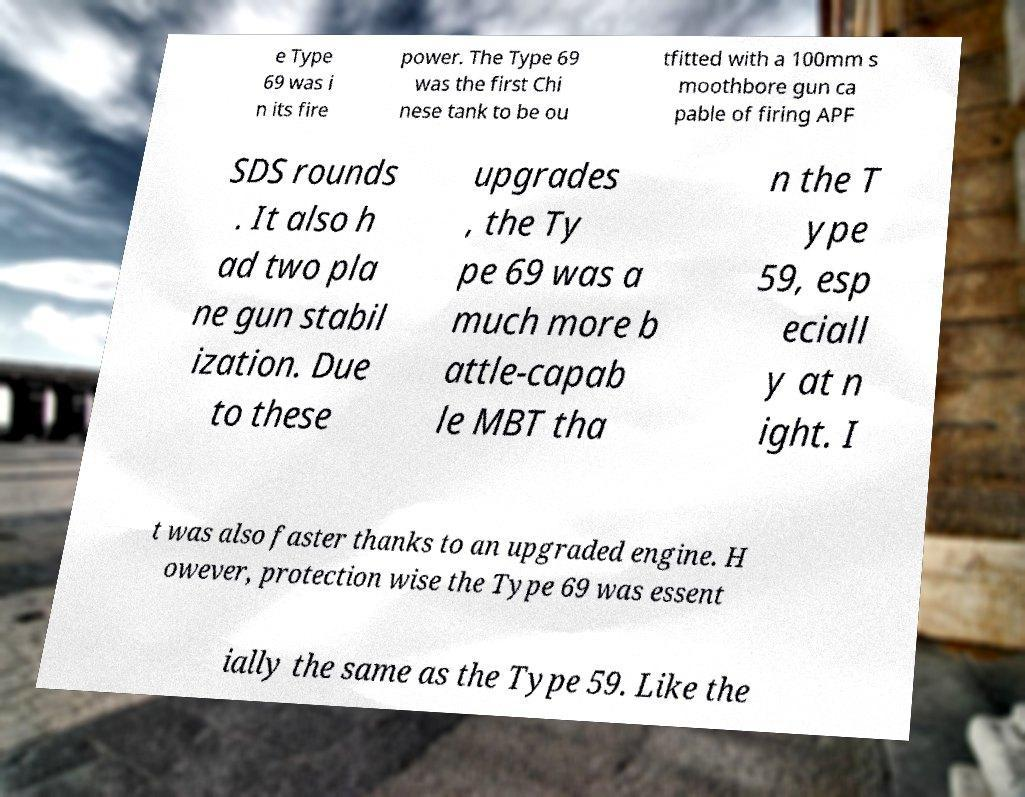For documentation purposes, I need the text within this image transcribed. Could you provide that? e Type 69 was i n its fire power. The Type 69 was the first Chi nese tank to be ou tfitted with a 100mm s moothbore gun ca pable of firing APF SDS rounds . It also h ad two pla ne gun stabil ization. Due to these upgrades , the Ty pe 69 was a much more b attle-capab le MBT tha n the T ype 59, esp eciall y at n ight. I t was also faster thanks to an upgraded engine. H owever, protection wise the Type 69 was essent ially the same as the Type 59. Like the 